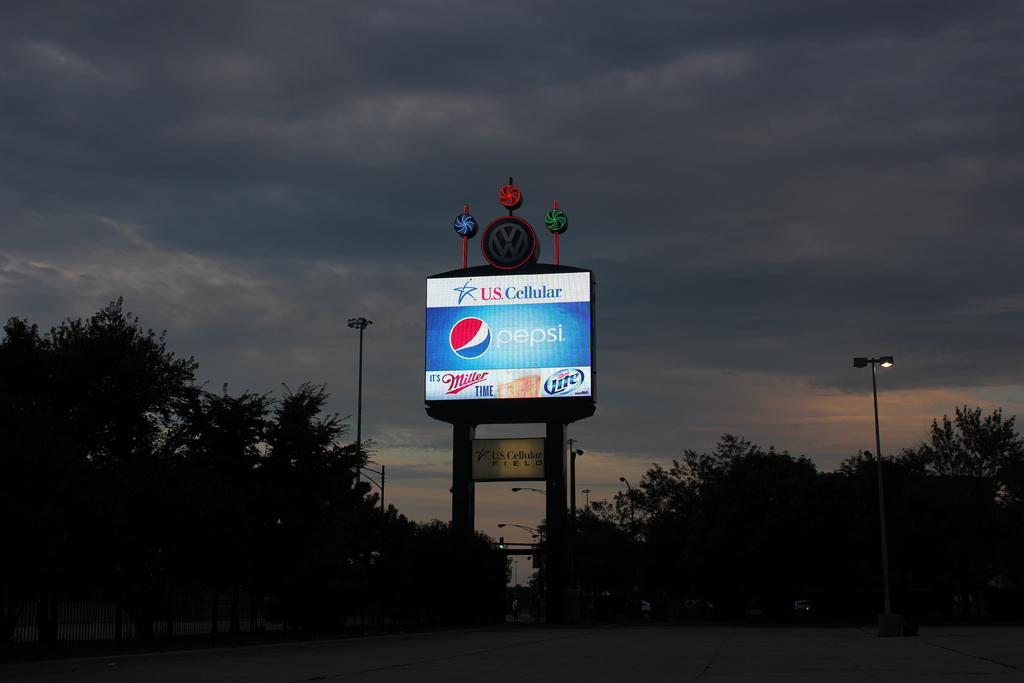What beer is advertising on the bottom?
Your answer should be very brief. Miller. 